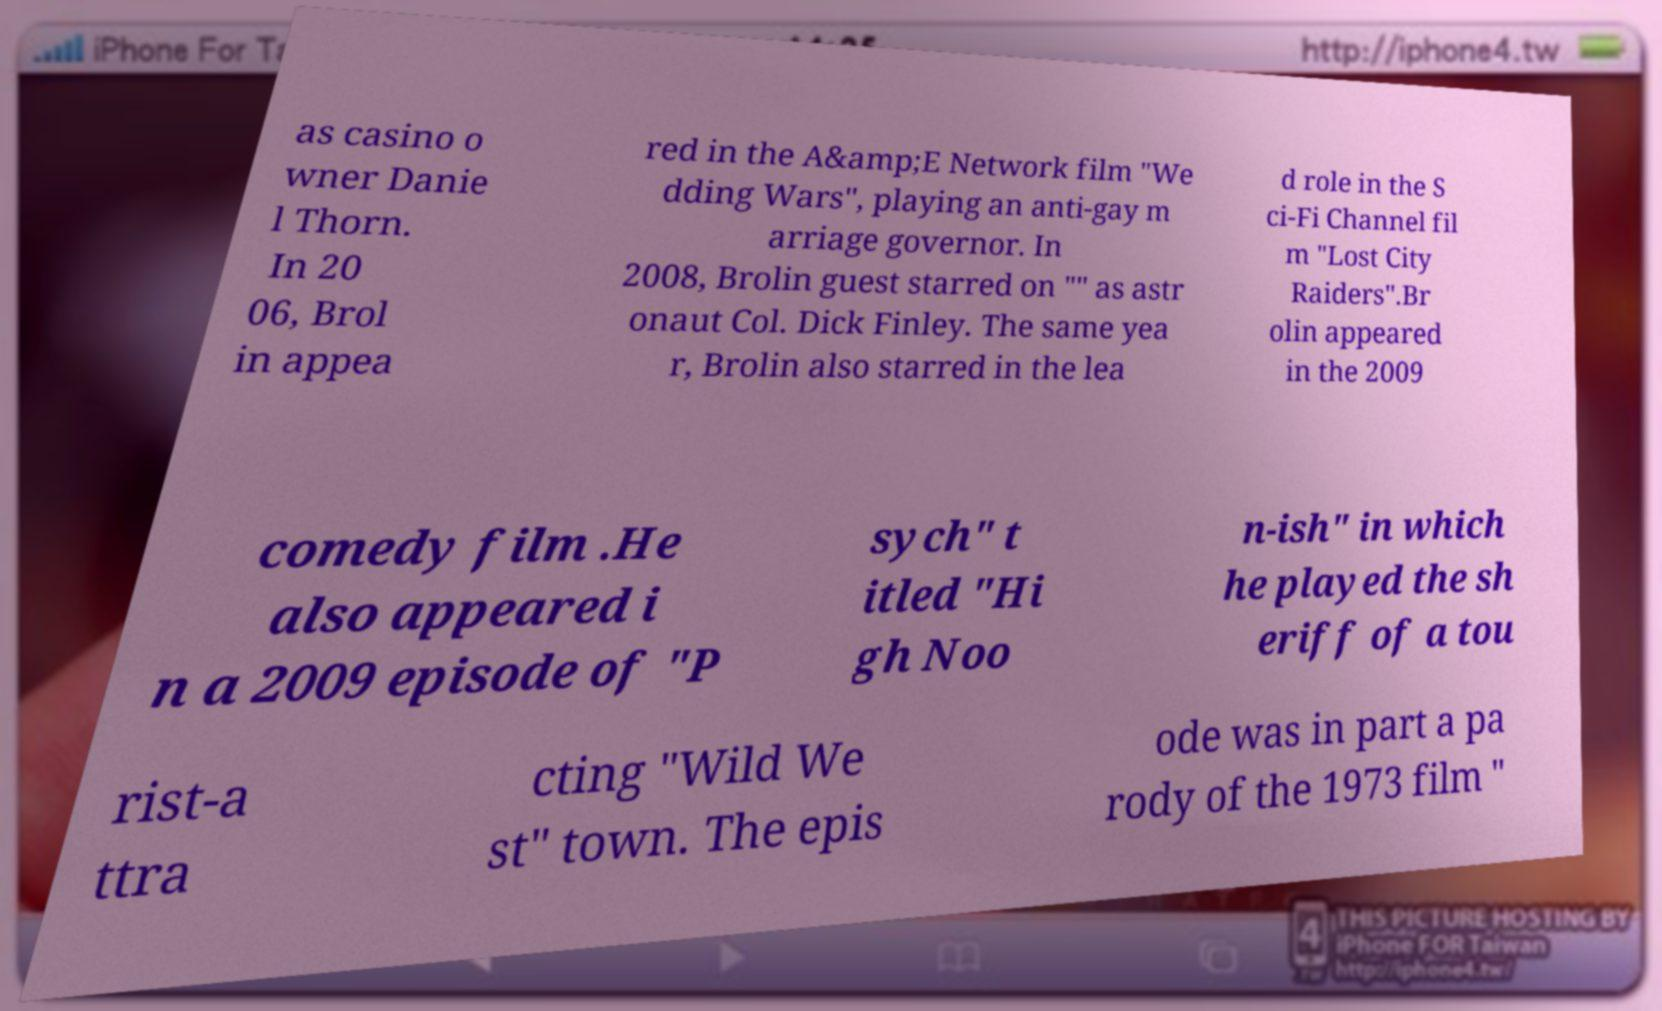Could you extract and type out the text from this image? as casino o wner Danie l Thorn. In 20 06, Brol in appea red in the A&amp;E Network film "We dding Wars", playing an anti-gay m arriage governor. In 2008, Brolin guest starred on "" as astr onaut Col. Dick Finley. The same yea r, Brolin also starred in the lea d role in the S ci-Fi Channel fil m "Lost City Raiders".Br olin appeared in the 2009 comedy film .He also appeared i n a 2009 episode of "P sych" t itled "Hi gh Noo n-ish" in which he played the sh eriff of a tou rist-a ttra cting "Wild We st" town. The epis ode was in part a pa rody of the 1973 film " 